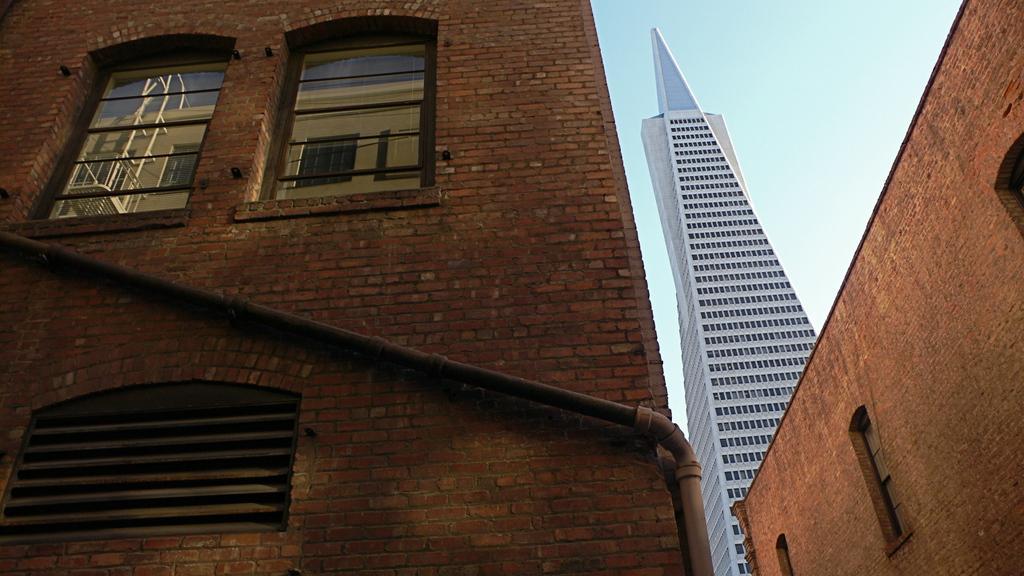How would you summarize this image in a sentence or two? In this picture we can see buildings, pipe and windows. In the background of the image we can see sky. 